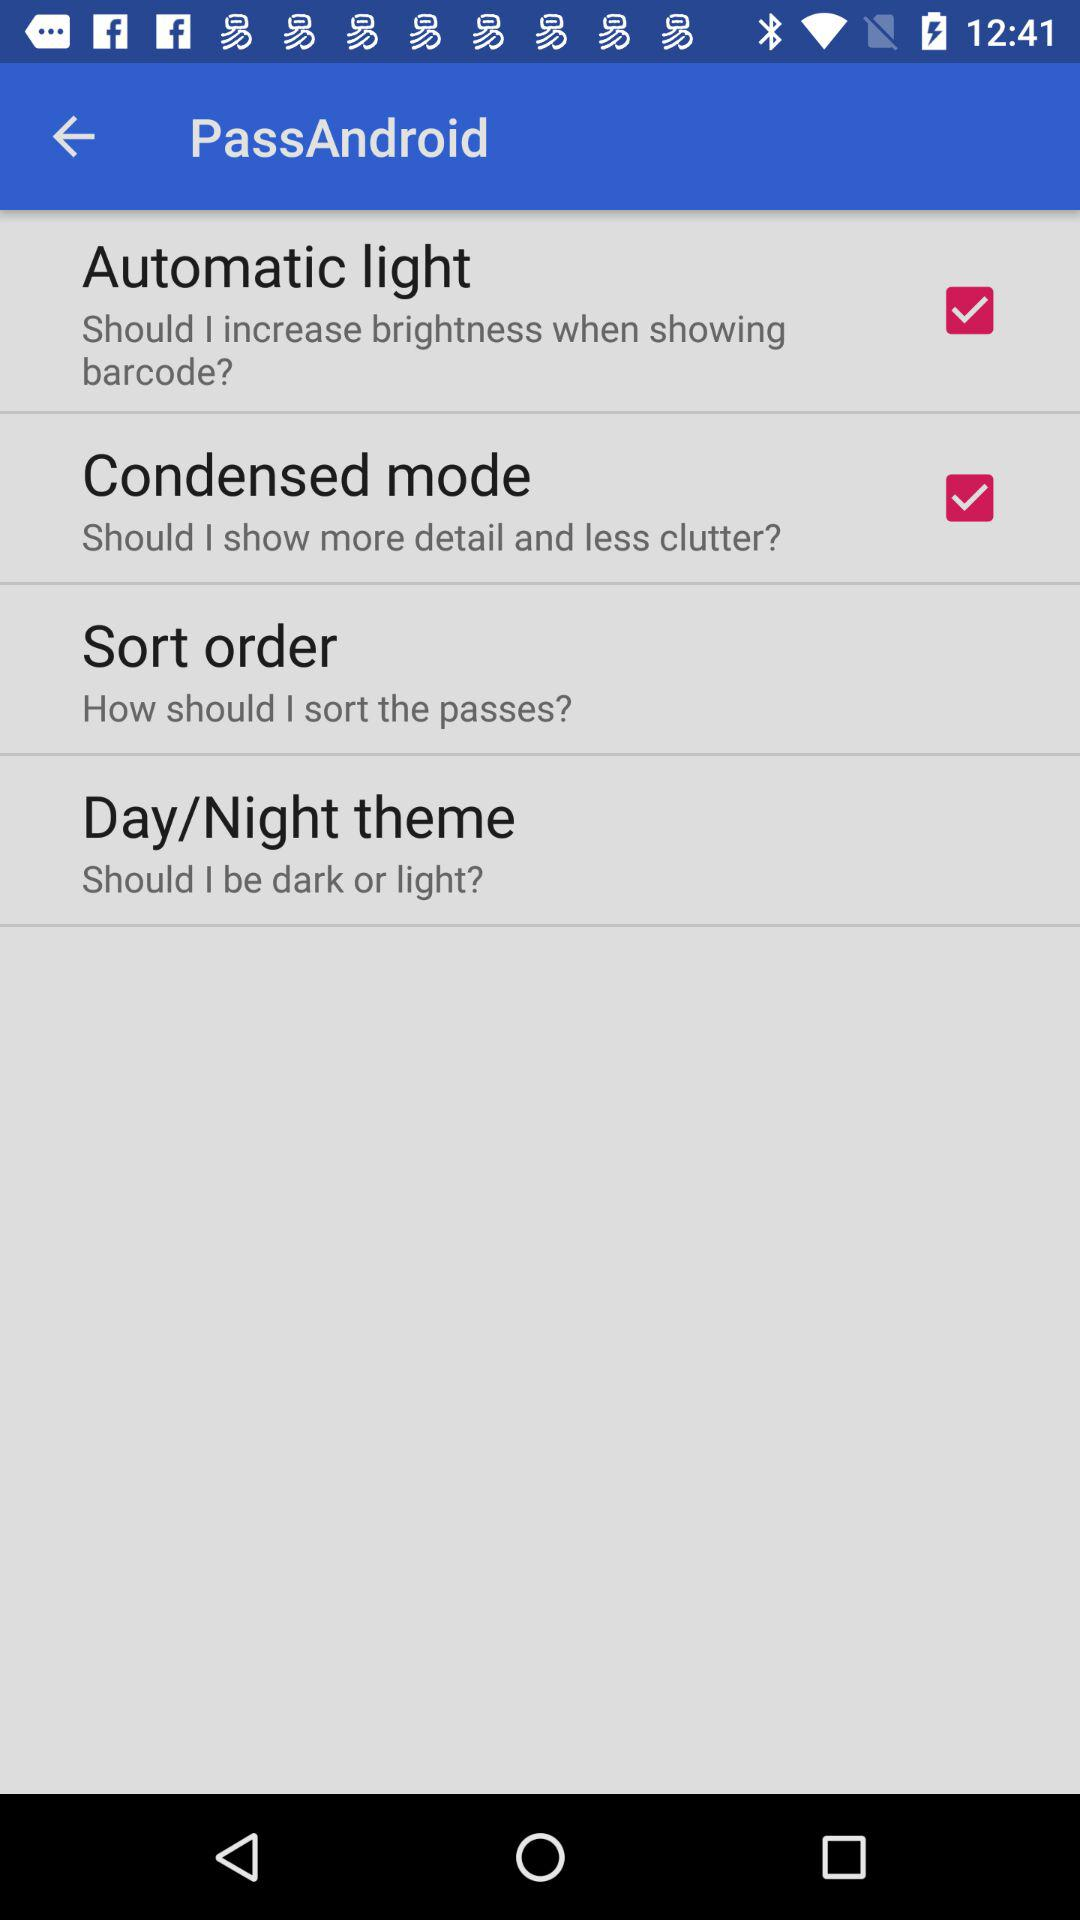What is the status of "Condensed mode"? The status is "on". 